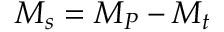<formula> <loc_0><loc_0><loc_500><loc_500>M _ { s } = M _ { P } - M _ { t }</formula> 